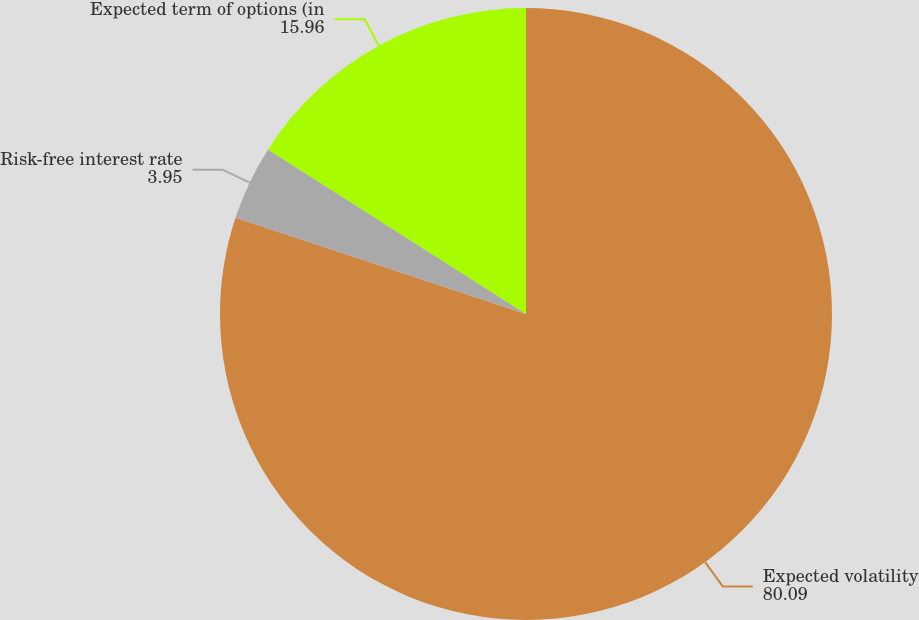Convert chart. <chart><loc_0><loc_0><loc_500><loc_500><pie_chart><fcel>Expected volatility<fcel>Risk-free interest rate<fcel>Expected term of options (in<nl><fcel>80.09%<fcel>3.95%<fcel>15.96%<nl></chart> 